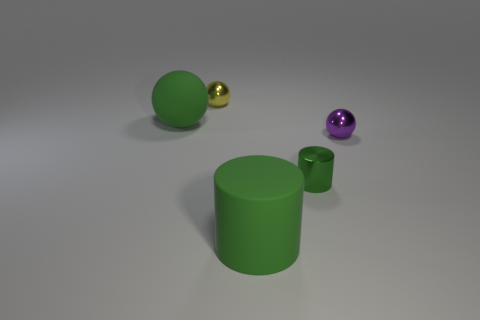How many other objects are the same shape as the tiny yellow metal object?
Provide a short and direct response. 2. The thing that is the same size as the green ball is what color?
Provide a short and direct response. Green. What number of objects are gray metal spheres or green cylinders?
Your answer should be very brief. 2. Are there any big green matte balls to the right of the purple sphere?
Keep it short and to the point. No. Is there a tiny purple sphere that has the same material as the big cylinder?
Make the answer very short. No. What size is the ball that is the same color as the matte cylinder?
Your response must be concise. Large. How many cylinders are either purple metallic objects or brown matte objects?
Offer a terse response. 0. Are there more large green spheres that are in front of the tiny purple shiny ball than small yellow balls that are in front of the big green matte cylinder?
Your answer should be compact. No. What number of tiny things are the same color as the large rubber sphere?
Offer a very short reply. 1. There is a purple object that is the same material as the small yellow thing; what is its size?
Offer a terse response. Small. 